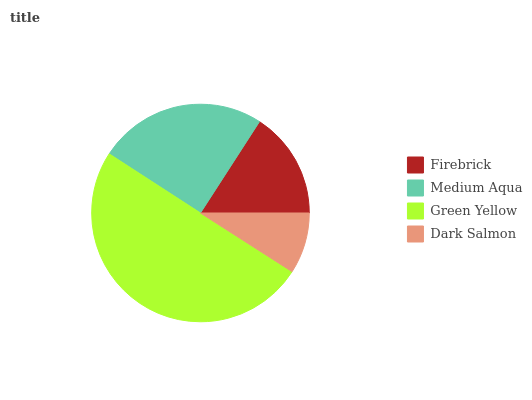Is Dark Salmon the minimum?
Answer yes or no. Yes. Is Green Yellow the maximum?
Answer yes or no. Yes. Is Medium Aqua the minimum?
Answer yes or no. No. Is Medium Aqua the maximum?
Answer yes or no. No. Is Medium Aqua greater than Firebrick?
Answer yes or no. Yes. Is Firebrick less than Medium Aqua?
Answer yes or no. Yes. Is Firebrick greater than Medium Aqua?
Answer yes or no. No. Is Medium Aqua less than Firebrick?
Answer yes or no. No. Is Medium Aqua the high median?
Answer yes or no. Yes. Is Firebrick the low median?
Answer yes or no. Yes. Is Green Yellow the high median?
Answer yes or no. No. Is Medium Aqua the low median?
Answer yes or no. No. 